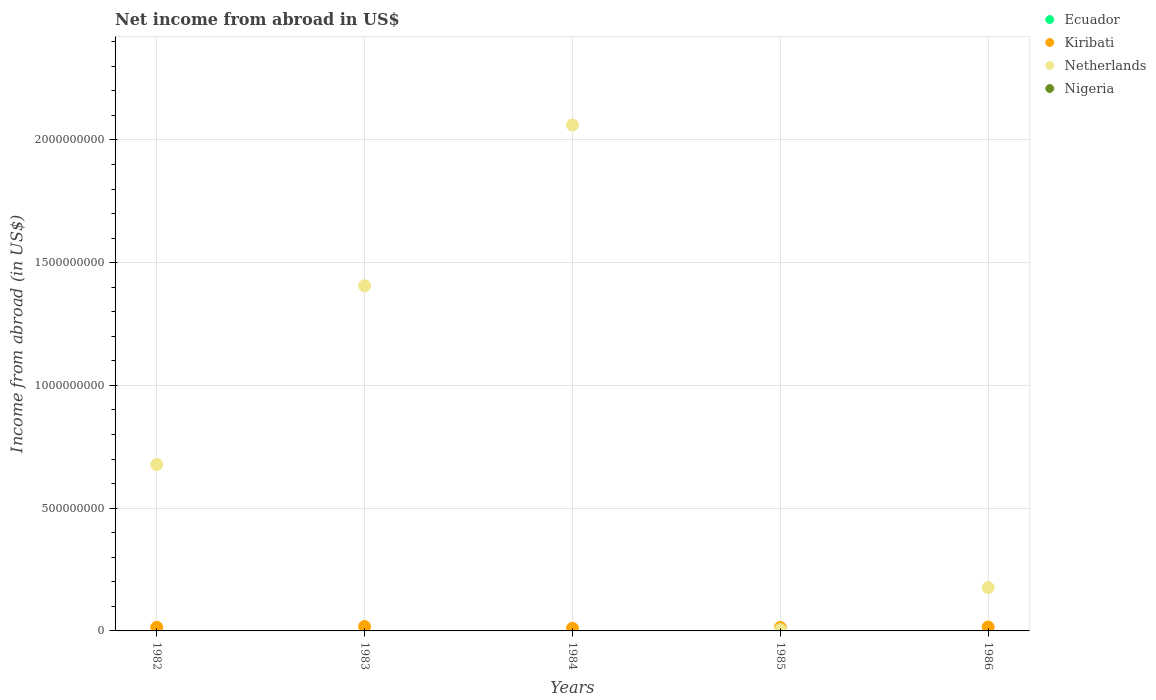How many different coloured dotlines are there?
Provide a short and direct response. 2. What is the net income from abroad in Ecuador in 1986?
Your response must be concise. 0. Across all years, what is the maximum net income from abroad in Netherlands?
Your answer should be very brief. 2.06e+09. Across all years, what is the minimum net income from abroad in Nigeria?
Your response must be concise. 0. What is the total net income from abroad in Kiribati in the graph?
Provide a succinct answer. 7.34e+07. What is the difference between the net income from abroad in Kiribati in 1984 and that in 1986?
Provide a short and direct response. -5.26e+06. What is the difference between the net income from abroad in Netherlands in 1984 and the net income from abroad in Kiribati in 1982?
Give a very brief answer. 2.05e+09. What is the average net income from abroad in Netherlands per year?
Your answer should be very brief. 8.65e+08. In the year 1983, what is the difference between the net income from abroad in Netherlands and net income from abroad in Kiribati?
Your answer should be very brief. 1.39e+09. What is the ratio of the net income from abroad in Kiribati in 1984 to that in 1986?
Provide a succinct answer. 0.67. Is the net income from abroad in Kiribati in 1982 less than that in 1983?
Your response must be concise. Yes. Is the difference between the net income from abroad in Netherlands in 1983 and 1984 greater than the difference between the net income from abroad in Kiribati in 1983 and 1984?
Offer a terse response. No. What is the difference between the highest and the second highest net income from abroad in Netherlands?
Ensure brevity in your answer.  6.55e+08. What is the difference between the highest and the lowest net income from abroad in Netherlands?
Keep it short and to the point. 2.06e+09. Is the sum of the net income from abroad in Kiribati in 1985 and 1986 greater than the maximum net income from abroad in Nigeria across all years?
Your answer should be compact. Yes. Does the net income from abroad in Netherlands monotonically increase over the years?
Your answer should be compact. No. Is the net income from abroad in Nigeria strictly greater than the net income from abroad in Kiribati over the years?
Your answer should be very brief. No. How many years are there in the graph?
Offer a terse response. 5. What is the difference between two consecutive major ticks on the Y-axis?
Your answer should be very brief. 5.00e+08. Where does the legend appear in the graph?
Your response must be concise. Top right. How many legend labels are there?
Your response must be concise. 4. What is the title of the graph?
Give a very brief answer. Net income from abroad in US$. What is the label or title of the X-axis?
Provide a succinct answer. Years. What is the label or title of the Y-axis?
Offer a terse response. Income from abroad (in US$). What is the Income from abroad (in US$) of Ecuador in 1982?
Make the answer very short. 0. What is the Income from abroad (in US$) in Kiribati in 1982?
Keep it short and to the point. 1.49e+07. What is the Income from abroad (in US$) in Netherlands in 1982?
Make the answer very short. 6.78e+08. What is the Income from abroad (in US$) of Ecuador in 1983?
Offer a terse response. 0. What is the Income from abroad (in US$) in Kiribati in 1983?
Keep it short and to the point. 1.78e+07. What is the Income from abroad (in US$) in Netherlands in 1983?
Offer a terse response. 1.41e+09. What is the Income from abroad (in US$) of Kiribati in 1984?
Your answer should be very brief. 1.07e+07. What is the Income from abroad (in US$) in Netherlands in 1984?
Ensure brevity in your answer.  2.06e+09. What is the Income from abroad (in US$) of Nigeria in 1984?
Offer a terse response. 0. What is the Income from abroad (in US$) in Kiribati in 1985?
Ensure brevity in your answer.  1.39e+07. What is the Income from abroad (in US$) of Netherlands in 1985?
Give a very brief answer. 5.53e+06. What is the Income from abroad (in US$) in Nigeria in 1985?
Your response must be concise. 0. What is the Income from abroad (in US$) of Kiribati in 1986?
Offer a very short reply. 1.60e+07. What is the Income from abroad (in US$) in Netherlands in 1986?
Keep it short and to the point. 1.77e+08. Across all years, what is the maximum Income from abroad (in US$) in Kiribati?
Your answer should be compact. 1.78e+07. Across all years, what is the maximum Income from abroad (in US$) in Netherlands?
Your answer should be very brief. 2.06e+09. Across all years, what is the minimum Income from abroad (in US$) in Kiribati?
Your answer should be very brief. 1.07e+07. Across all years, what is the minimum Income from abroad (in US$) of Netherlands?
Ensure brevity in your answer.  5.53e+06. What is the total Income from abroad (in US$) of Kiribati in the graph?
Your answer should be very brief. 7.34e+07. What is the total Income from abroad (in US$) in Netherlands in the graph?
Your answer should be compact. 4.33e+09. What is the difference between the Income from abroad (in US$) in Kiribati in 1982 and that in 1983?
Your response must be concise. -2.92e+06. What is the difference between the Income from abroad (in US$) of Netherlands in 1982 and that in 1983?
Provide a short and direct response. -7.28e+08. What is the difference between the Income from abroad (in US$) in Kiribati in 1982 and that in 1984?
Ensure brevity in your answer.  4.16e+06. What is the difference between the Income from abroad (in US$) in Netherlands in 1982 and that in 1984?
Make the answer very short. -1.38e+09. What is the difference between the Income from abroad (in US$) of Kiribati in 1982 and that in 1985?
Offer a very short reply. 9.64e+05. What is the difference between the Income from abroad (in US$) of Netherlands in 1982 and that in 1985?
Keep it short and to the point. 6.72e+08. What is the difference between the Income from abroad (in US$) of Kiribati in 1982 and that in 1986?
Give a very brief answer. -1.10e+06. What is the difference between the Income from abroad (in US$) of Netherlands in 1982 and that in 1986?
Offer a terse response. 5.01e+08. What is the difference between the Income from abroad (in US$) of Kiribati in 1983 and that in 1984?
Your answer should be very brief. 7.07e+06. What is the difference between the Income from abroad (in US$) in Netherlands in 1983 and that in 1984?
Your answer should be compact. -6.55e+08. What is the difference between the Income from abroad (in US$) of Kiribati in 1983 and that in 1985?
Offer a very short reply. 3.88e+06. What is the difference between the Income from abroad (in US$) in Netherlands in 1983 and that in 1985?
Provide a succinct answer. 1.40e+09. What is the difference between the Income from abroad (in US$) of Kiribati in 1983 and that in 1986?
Provide a short and direct response. 1.82e+06. What is the difference between the Income from abroad (in US$) in Netherlands in 1983 and that in 1986?
Ensure brevity in your answer.  1.23e+09. What is the difference between the Income from abroad (in US$) of Kiribati in 1984 and that in 1985?
Your answer should be very brief. -3.19e+06. What is the difference between the Income from abroad (in US$) of Netherlands in 1984 and that in 1985?
Your answer should be very brief. 2.06e+09. What is the difference between the Income from abroad (in US$) of Kiribati in 1984 and that in 1986?
Offer a very short reply. -5.26e+06. What is the difference between the Income from abroad (in US$) of Netherlands in 1984 and that in 1986?
Keep it short and to the point. 1.88e+09. What is the difference between the Income from abroad (in US$) in Kiribati in 1985 and that in 1986?
Offer a very short reply. -2.06e+06. What is the difference between the Income from abroad (in US$) of Netherlands in 1985 and that in 1986?
Your answer should be very brief. -1.71e+08. What is the difference between the Income from abroad (in US$) of Kiribati in 1982 and the Income from abroad (in US$) of Netherlands in 1983?
Give a very brief answer. -1.39e+09. What is the difference between the Income from abroad (in US$) in Kiribati in 1982 and the Income from abroad (in US$) in Netherlands in 1984?
Ensure brevity in your answer.  -2.05e+09. What is the difference between the Income from abroad (in US$) of Kiribati in 1982 and the Income from abroad (in US$) of Netherlands in 1985?
Keep it short and to the point. 9.37e+06. What is the difference between the Income from abroad (in US$) of Kiribati in 1982 and the Income from abroad (in US$) of Netherlands in 1986?
Give a very brief answer. -1.62e+08. What is the difference between the Income from abroad (in US$) of Kiribati in 1983 and the Income from abroad (in US$) of Netherlands in 1984?
Your response must be concise. -2.04e+09. What is the difference between the Income from abroad (in US$) in Kiribati in 1983 and the Income from abroad (in US$) in Netherlands in 1985?
Your answer should be very brief. 1.23e+07. What is the difference between the Income from abroad (in US$) of Kiribati in 1983 and the Income from abroad (in US$) of Netherlands in 1986?
Your answer should be compact. -1.59e+08. What is the difference between the Income from abroad (in US$) of Kiribati in 1984 and the Income from abroad (in US$) of Netherlands in 1985?
Your response must be concise. 5.21e+06. What is the difference between the Income from abroad (in US$) in Kiribati in 1984 and the Income from abroad (in US$) in Netherlands in 1986?
Offer a very short reply. -1.66e+08. What is the difference between the Income from abroad (in US$) in Kiribati in 1985 and the Income from abroad (in US$) in Netherlands in 1986?
Your answer should be very brief. -1.63e+08. What is the average Income from abroad (in US$) of Ecuador per year?
Provide a short and direct response. 0. What is the average Income from abroad (in US$) of Kiribati per year?
Your answer should be compact. 1.47e+07. What is the average Income from abroad (in US$) in Netherlands per year?
Your response must be concise. 8.65e+08. What is the average Income from abroad (in US$) in Nigeria per year?
Offer a very short reply. 0. In the year 1982, what is the difference between the Income from abroad (in US$) of Kiribati and Income from abroad (in US$) of Netherlands?
Your answer should be compact. -6.63e+08. In the year 1983, what is the difference between the Income from abroad (in US$) in Kiribati and Income from abroad (in US$) in Netherlands?
Offer a terse response. -1.39e+09. In the year 1984, what is the difference between the Income from abroad (in US$) of Kiribati and Income from abroad (in US$) of Netherlands?
Keep it short and to the point. -2.05e+09. In the year 1985, what is the difference between the Income from abroad (in US$) in Kiribati and Income from abroad (in US$) in Netherlands?
Your answer should be very brief. 8.41e+06. In the year 1986, what is the difference between the Income from abroad (in US$) in Kiribati and Income from abroad (in US$) in Netherlands?
Your answer should be very brief. -1.61e+08. What is the ratio of the Income from abroad (in US$) of Kiribati in 1982 to that in 1983?
Your answer should be compact. 0.84. What is the ratio of the Income from abroad (in US$) of Netherlands in 1982 to that in 1983?
Make the answer very short. 0.48. What is the ratio of the Income from abroad (in US$) of Kiribati in 1982 to that in 1984?
Your answer should be compact. 1.39. What is the ratio of the Income from abroad (in US$) in Netherlands in 1982 to that in 1984?
Make the answer very short. 0.33. What is the ratio of the Income from abroad (in US$) of Kiribati in 1982 to that in 1985?
Offer a very short reply. 1.07. What is the ratio of the Income from abroad (in US$) in Netherlands in 1982 to that in 1985?
Provide a short and direct response. 122.5. What is the ratio of the Income from abroad (in US$) in Kiribati in 1982 to that in 1986?
Keep it short and to the point. 0.93. What is the ratio of the Income from abroad (in US$) in Netherlands in 1982 to that in 1986?
Your answer should be compact. 3.84. What is the ratio of the Income from abroad (in US$) in Kiribati in 1983 to that in 1984?
Give a very brief answer. 1.66. What is the ratio of the Income from abroad (in US$) in Netherlands in 1983 to that in 1984?
Your answer should be very brief. 0.68. What is the ratio of the Income from abroad (in US$) of Kiribati in 1983 to that in 1985?
Keep it short and to the point. 1.28. What is the ratio of the Income from abroad (in US$) in Netherlands in 1983 to that in 1985?
Offer a very short reply. 254.06. What is the ratio of the Income from abroad (in US$) of Kiribati in 1983 to that in 1986?
Your response must be concise. 1.11. What is the ratio of the Income from abroad (in US$) of Netherlands in 1983 to that in 1986?
Your answer should be compact. 7.96. What is the ratio of the Income from abroad (in US$) in Kiribati in 1984 to that in 1985?
Offer a very short reply. 0.77. What is the ratio of the Income from abroad (in US$) in Netherlands in 1984 to that in 1985?
Your answer should be compact. 372.35. What is the ratio of the Income from abroad (in US$) of Kiribati in 1984 to that in 1986?
Offer a very short reply. 0.67. What is the ratio of the Income from abroad (in US$) of Netherlands in 1984 to that in 1986?
Offer a very short reply. 11.67. What is the ratio of the Income from abroad (in US$) in Kiribati in 1985 to that in 1986?
Offer a terse response. 0.87. What is the ratio of the Income from abroad (in US$) of Netherlands in 1985 to that in 1986?
Provide a succinct answer. 0.03. What is the difference between the highest and the second highest Income from abroad (in US$) of Kiribati?
Make the answer very short. 1.82e+06. What is the difference between the highest and the second highest Income from abroad (in US$) in Netherlands?
Offer a very short reply. 6.55e+08. What is the difference between the highest and the lowest Income from abroad (in US$) in Kiribati?
Offer a terse response. 7.07e+06. What is the difference between the highest and the lowest Income from abroad (in US$) of Netherlands?
Provide a succinct answer. 2.06e+09. 